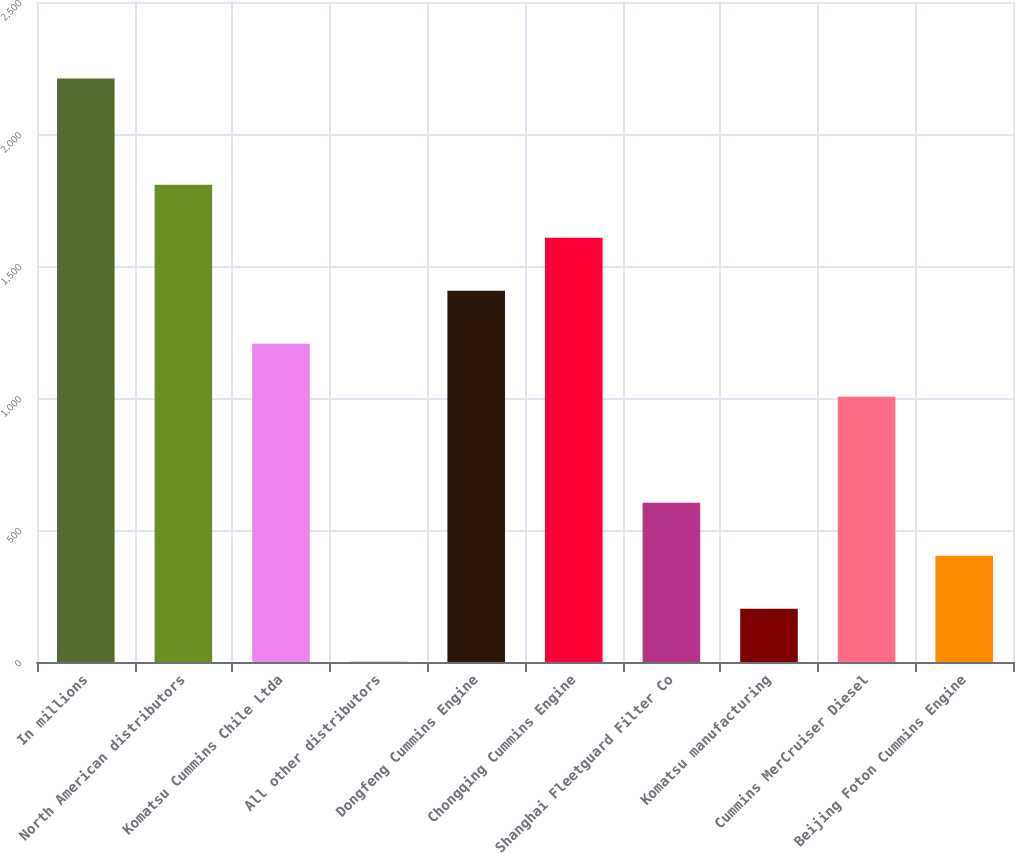<chart> <loc_0><loc_0><loc_500><loc_500><bar_chart><fcel>In millions<fcel>North American distributors<fcel>Komatsu Cummins Chile Ltda<fcel>All other distributors<fcel>Dongfeng Cummins Engine<fcel>Chongqing Cummins Engine<fcel>Shanghai Fleetguard Filter Co<fcel>Komatsu manufacturing<fcel>Cummins MerCruiser Diesel<fcel>Beijing Foton Cummins Engine<nl><fcel>2209.8<fcel>1808.2<fcel>1205.8<fcel>1<fcel>1406.6<fcel>1607.4<fcel>603.4<fcel>201.8<fcel>1005<fcel>402.6<nl></chart> 